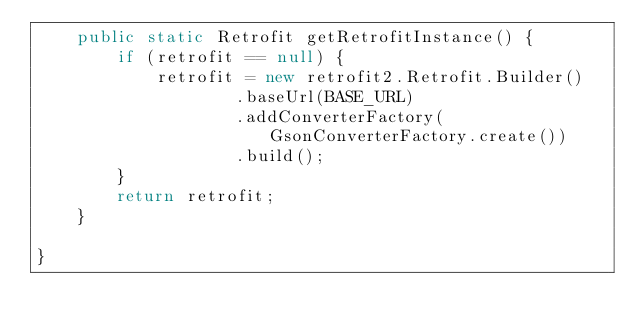<code> <loc_0><loc_0><loc_500><loc_500><_Java_>    public static Retrofit getRetrofitInstance() {
        if (retrofit == null) {
            retrofit = new retrofit2.Retrofit.Builder()
                    .baseUrl(BASE_URL)
                    .addConverterFactory(GsonConverterFactory.create())
                    .build();
        }
        return retrofit;
    }

}
</code> 